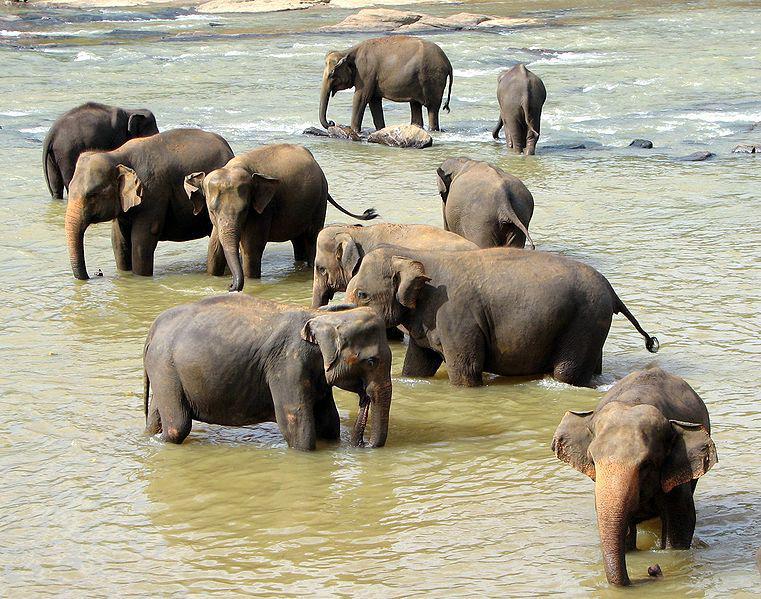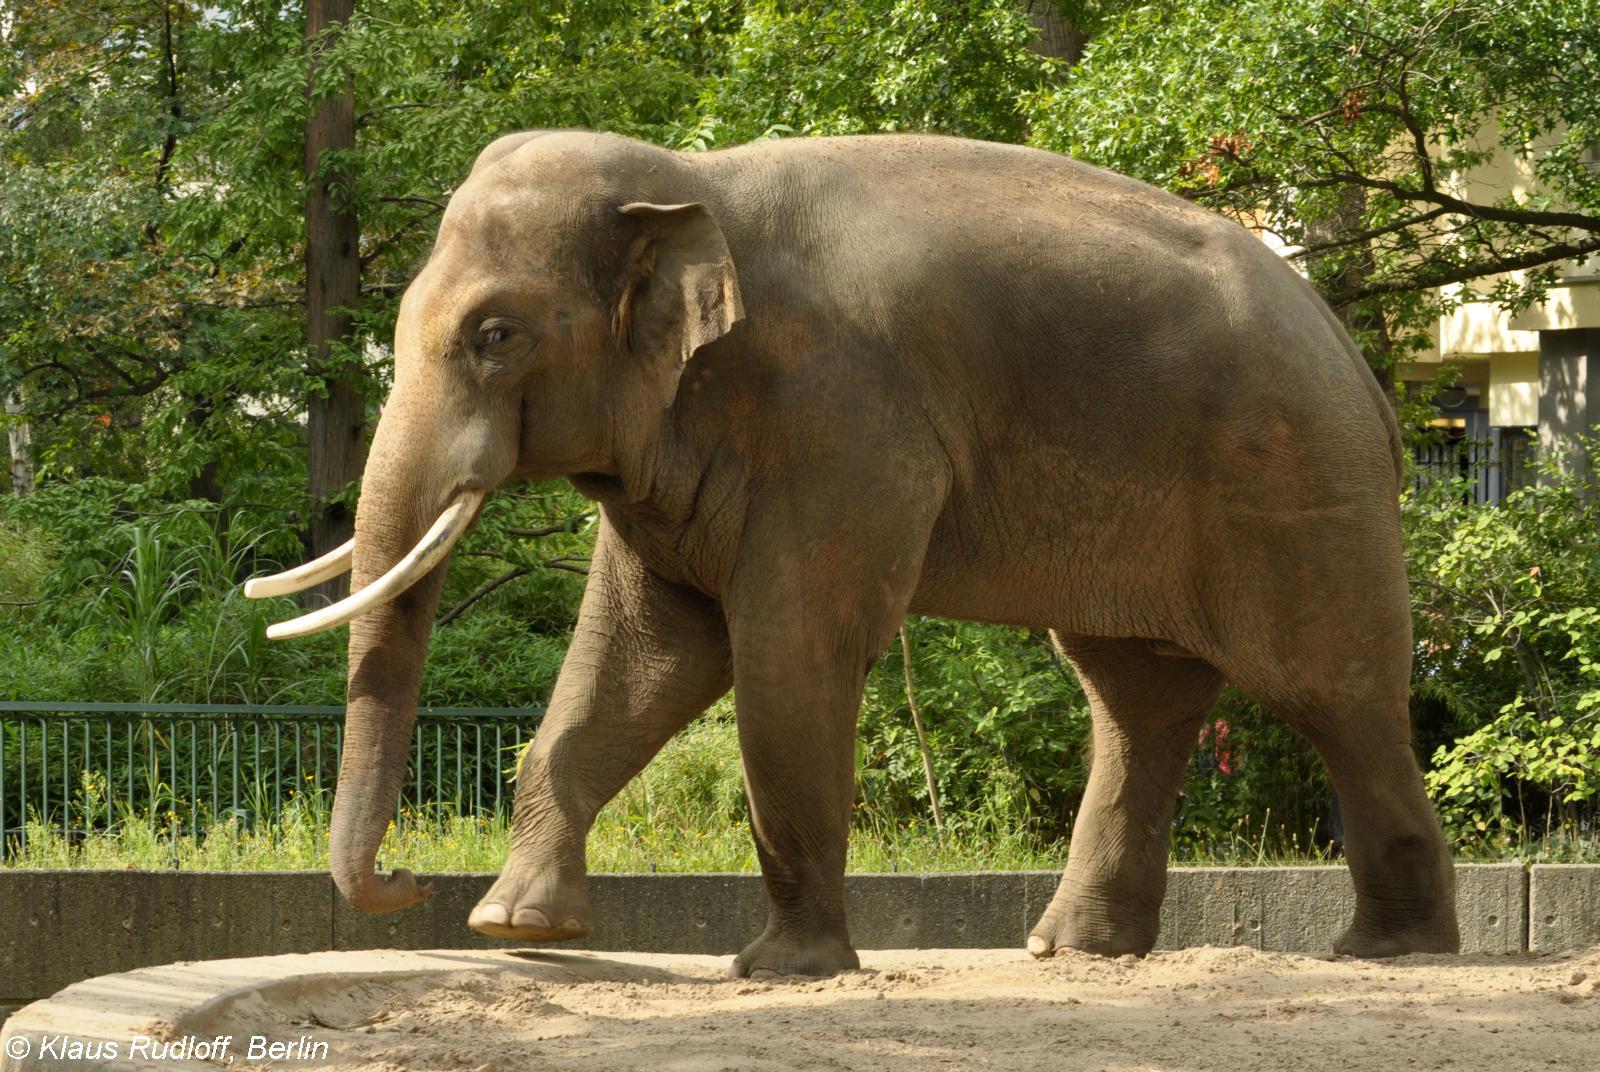The first image is the image on the left, the second image is the image on the right. Assess this claim about the two images: "Left and right images depict one elephant, which has tusks.". Correct or not? Answer yes or no. No. The first image is the image on the left, the second image is the image on the right. Analyze the images presented: Is the assertion "Exactly one adult elephant with long, white ivory tusks is depicted in each image." valid? Answer yes or no. No. 